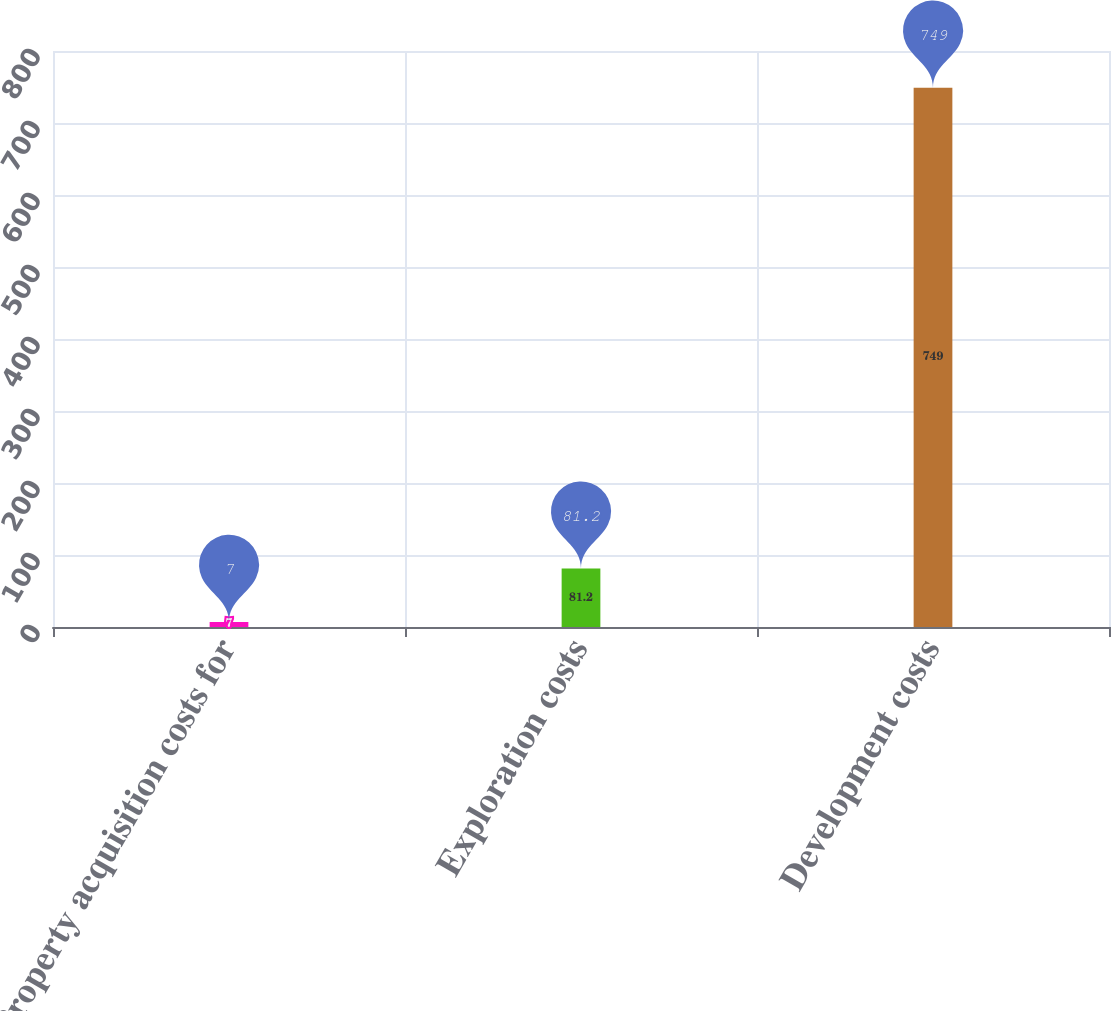Convert chart. <chart><loc_0><loc_0><loc_500><loc_500><bar_chart><fcel>Property acquisition costs for<fcel>Exploration costs<fcel>Development costs<nl><fcel>7<fcel>81.2<fcel>749<nl></chart> 